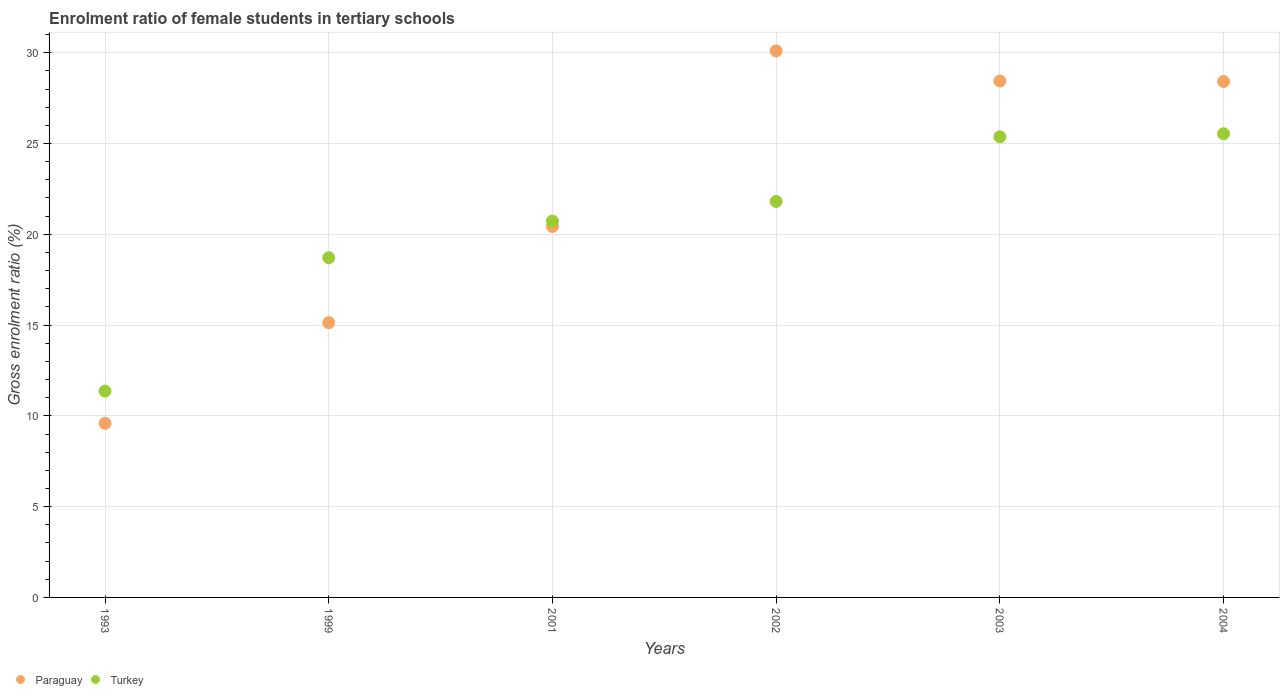How many different coloured dotlines are there?
Keep it short and to the point. 2. Is the number of dotlines equal to the number of legend labels?
Offer a terse response. Yes. What is the enrolment ratio of female students in tertiary schools in Paraguay in 1999?
Your answer should be compact. 15.14. Across all years, what is the maximum enrolment ratio of female students in tertiary schools in Paraguay?
Make the answer very short. 30.1. Across all years, what is the minimum enrolment ratio of female students in tertiary schools in Turkey?
Your answer should be very brief. 11.36. What is the total enrolment ratio of female students in tertiary schools in Turkey in the graph?
Give a very brief answer. 123.52. What is the difference between the enrolment ratio of female students in tertiary schools in Turkey in 1999 and that in 2003?
Offer a very short reply. -6.66. What is the difference between the enrolment ratio of female students in tertiary schools in Paraguay in 2003 and the enrolment ratio of female students in tertiary schools in Turkey in 2001?
Provide a succinct answer. 7.71. What is the average enrolment ratio of female students in tertiary schools in Paraguay per year?
Offer a very short reply. 22.02. In the year 1999, what is the difference between the enrolment ratio of female students in tertiary schools in Turkey and enrolment ratio of female students in tertiary schools in Paraguay?
Provide a short and direct response. 3.57. What is the ratio of the enrolment ratio of female students in tertiary schools in Turkey in 1993 to that in 2001?
Your answer should be compact. 0.55. Is the enrolment ratio of female students in tertiary schools in Turkey in 2003 less than that in 2004?
Give a very brief answer. Yes. What is the difference between the highest and the second highest enrolment ratio of female students in tertiary schools in Turkey?
Your answer should be very brief. 0.17. What is the difference between the highest and the lowest enrolment ratio of female students in tertiary schools in Paraguay?
Keep it short and to the point. 20.51. Is the sum of the enrolment ratio of female students in tertiary schools in Paraguay in 1999 and 2001 greater than the maximum enrolment ratio of female students in tertiary schools in Turkey across all years?
Ensure brevity in your answer.  Yes. Does the enrolment ratio of female students in tertiary schools in Paraguay monotonically increase over the years?
Make the answer very short. No. How many dotlines are there?
Your answer should be very brief. 2. Are the values on the major ticks of Y-axis written in scientific E-notation?
Provide a short and direct response. No. Where does the legend appear in the graph?
Make the answer very short. Bottom left. How many legend labels are there?
Ensure brevity in your answer.  2. How are the legend labels stacked?
Provide a short and direct response. Horizontal. What is the title of the graph?
Offer a terse response. Enrolment ratio of female students in tertiary schools. What is the label or title of the Y-axis?
Provide a short and direct response. Gross enrolment ratio (%). What is the Gross enrolment ratio (%) in Paraguay in 1993?
Provide a short and direct response. 9.59. What is the Gross enrolment ratio (%) of Turkey in 1993?
Give a very brief answer. 11.36. What is the Gross enrolment ratio (%) in Paraguay in 1999?
Your answer should be compact. 15.14. What is the Gross enrolment ratio (%) of Turkey in 1999?
Provide a succinct answer. 18.71. What is the Gross enrolment ratio (%) in Paraguay in 2001?
Your response must be concise. 20.43. What is the Gross enrolment ratio (%) of Turkey in 2001?
Offer a terse response. 20.73. What is the Gross enrolment ratio (%) in Paraguay in 2002?
Keep it short and to the point. 30.1. What is the Gross enrolment ratio (%) of Turkey in 2002?
Provide a succinct answer. 21.81. What is the Gross enrolment ratio (%) of Paraguay in 2003?
Make the answer very short. 28.44. What is the Gross enrolment ratio (%) of Turkey in 2003?
Your response must be concise. 25.37. What is the Gross enrolment ratio (%) in Paraguay in 2004?
Provide a short and direct response. 28.42. What is the Gross enrolment ratio (%) of Turkey in 2004?
Offer a terse response. 25.54. Across all years, what is the maximum Gross enrolment ratio (%) of Paraguay?
Make the answer very short. 30.1. Across all years, what is the maximum Gross enrolment ratio (%) of Turkey?
Offer a very short reply. 25.54. Across all years, what is the minimum Gross enrolment ratio (%) in Paraguay?
Offer a terse response. 9.59. Across all years, what is the minimum Gross enrolment ratio (%) in Turkey?
Offer a terse response. 11.36. What is the total Gross enrolment ratio (%) of Paraguay in the graph?
Give a very brief answer. 132.12. What is the total Gross enrolment ratio (%) of Turkey in the graph?
Keep it short and to the point. 123.52. What is the difference between the Gross enrolment ratio (%) of Paraguay in 1993 and that in 1999?
Give a very brief answer. -5.55. What is the difference between the Gross enrolment ratio (%) in Turkey in 1993 and that in 1999?
Your answer should be very brief. -7.34. What is the difference between the Gross enrolment ratio (%) in Paraguay in 1993 and that in 2001?
Offer a very short reply. -10.84. What is the difference between the Gross enrolment ratio (%) in Turkey in 1993 and that in 2001?
Ensure brevity in your answer.  -9.37. What is the difference between the Gross enrolment ratio (%) of Paraguay in 1993 and that in 2002?
Ensure brevity in your answer.  -20.51. What is the difference between the Gross enrolment ratio (%) in Turkey in 1993 and that in 2002?
Your answer should be compact. -10.45. What is the difference between the Gross enrolment ratio (%) in Paraguay in 1993 and that in 2003?
Provide a succinct answer. -18.85. What is the difference between the Gross enrolment ratio (%) of Turkey in 1993 and that in 2003?
Keep it short and to the point. -14.01. What is the difference between the Gross enrolment ratio (%) in Paraguay in 1993 and that in 2004?
Your answer should be compact. -18.83. What is the difference between the Gross enrolment ratio (%) of Turkey in 1993 and that in 2004?
Provide a short and direct response. -14.17. What is the difference between the Gross enrolment ratio (%) of Paraguay in 1999 and that in 2001?
Give a very brief answer. -5.29. What is the difference between the Gross enrolment ratio (%) in Turkey in 1999 and that in 2001?
Your response must be concise. -2.02. What is the difference between the Gross enrolment ratio (%) in Paraguay in 1999 and that in 2002?
Provide a succinct answer. -14.97. What is the difference between the Gross enrolment ratio (%) in Turkey in 1999 and that in 2002?
Keep it short and to the point. -3.1. What is the difference between the Gross enrolment ratio (%) in Paraguay in 1999 and that in 2003?
Provide a short and direct response. -13.31. What is the difference between the Gross enrolment ratio (%) of Turkey in 1999 and that in 2003?
Your answer should be very brief. -6.66. What is the difference between the Gross enrolment ratio (%) of Paraguay in 1999 and that in 2004?
Your answer should be compact. -13.28. What is the difference between the Gross enrolment ratio (%) of Turkey in 1999 and that in 2004?
Your answer should be very brief. -6.83. What is the difference between the Gross enrolment ratio (%) of Paraguay in 2001 and that in 2002?
Ensure brevity in your answer.  -9.67. What is the difference between the Gross enrolment ratio (%) of Turkey in 2001 and that in 2002?
Make the answer very short. -1.08. What is the difference between the Gross enrolment ratio (%) in Paraguay in 2001 and that in 2003?
Provide a succinct answer. -8.01. What is the difference between the Gross enrolment ratio (%) of Turkey in 2001 and that in 2003?
Offer a terse response. -4.64. What is the difference between the Gross enrolment ratio (%) of Paraguay in 2001 and that in 2004?
Provide a succinct answer. -7.98. What is the difference between the Gross enrolment ratio (%) of Turkey in 2001 and that in 2004?
Provide a short and direct response. -4.81. What is the difference between the Gross enrolment ratio (%) of Paraguay in 2002 and that in 2003?
Your response must be concise. 1.66. What is the difference between the Gross enrolment ratio (%) in Turkey in 2002 and that in 2003?
Offer a terse response. -3.56. What is the difference between the Gross enrolment ratio (%) of Paraguay in 2002 and that in 2004?
Keep it short and to the point. 1.69. What is the difference between the Gross enrolment ratio (%) of Turkey in 2002 and that in 2004?
Offer a very short reply. -3.73. What is the difference between the Gross enrolment ratio (%) of Paraguay in 2003 and that in 2004?
Your answer should be compact. 0.03. What is the difference between the Gross enrolment ratio (%) of Turkey in 2003 and that in 2004?
Your response must be concise. -0.17. What is the difference between the Gross enrolment ratio (%) in Paraguay in 1993 and the Gross enrolment ratio (%) in Turkey in 1999?
Your answer should be very brief. -9.12. What is the difference between the Gross enrolment ratio (%) of Paraguay in 1993 and the Gross enrolment ratio (%) of Turkey in 2001?
Your answer should be compact. -11.14. What is the difference between the Gross enrolment ratio (%) of Paraguay in 1993 and the Gross enrolment ratio (%) of Turkey in 2002?
Provide a short and direct response. -12.22. What is the difference between the Gross enrolment ratio (%) in Paraguay in 1993 and the Gross enrolment ratio (%) in Turkey in 2003?
Keep it short and to the point. -15.78. What is the difference between the Gross enrolment ratio (%) of Paraguay in 1993 and the Gross enrolment ratio (%) of Turkey in 2004?
Your response must be concise. -15.95. What is the difference between the Gross enrolment ratio (%) in Paraguay in 1999 and the Gross enrolment ratio (%) in Turkey in 2001?
Your answer should be compact. -5.59. What is the difference between the Gross enrolment ratio (%) of Paraguay in 1999 and the Gross enrolment ratio (%) of Turkey in 2002?
Your response must be concise. -6.67. What is the difference between the Gross enrolment ratio (%) of Paraguay in 1999 and the Gross enrolment ratio (%) of Turkey in 2003?
Make the answer very short. -10.23. What is the difference between the Gross enrolment ratio (%) of Paraguay in 1999 and the Gross enrolment ratio (%) of Turkey in 2004?
Give a very brief answer. -10.4. What is the difference between the Gross enrolment ratio (%) of Paraguay in 2001 and the Gross enrolment ratio (%) of Turkey in 2002?
Ensure brevity in your answer.  -1.38. What is the difference between the Gross enrolment ratio (%) of Paraguay in 2001 and the Gross enrolment ratio (%) of Turkey in 2003?
Your answer should be compact. -4.94. What is the difference between the Gross enrolment ratio (%) in Paraguay in 2001 and the Gross enrolment ratio (%) in Turkey in 2004?
Your response must be concise. -5.11. What is the difference between the Gross enrolment ratio (%) of Paraguay in 2002 and the Gross enrolment ratio (%) of Turkey in 2003?
Your response must be concise. 4.73. What is the difference between the Gross enrolment ratio (%) in Paraguay in 2002 and the Gross enrolment ratio (%) in Turkey in 2004?
Your answer should be very brief. 4.56. What is the difference between the Gross enrolment ratio (%) in Paraguay in 2003 and the Gross enrolment ratio (%) in Turkey in 2004?
Offer a very short reply. 2.91. What is the average Gross enrolment ratio (%) of Paraguay per year?
Keep it short and to the point. 22.02. What is the average Gross enrolment ratio (%) of Turkey per year?
Keep it short and to the point. 20.59. In the year 1993, what is the difference between the Gross enrolment ratio (%) in Paraguay and Gross enrolment ratio (%) in Turkey?
Keep it short and to the point. -1.77. In the year 1999, what is the difference between the Gross enrolment ratio (%) of Paraguay and Gross enrolment ratio (%) of Turkey?
Make the answer very short. -3.57. In the year 2001, what is the difference between the Gross enrolment ratio (%) in Paraguay and Gross enrolment ratio (%) in Turkey?
Your answer should be very brief. -0.3. In the year 2002, what is the difference between the Gross enrolment ratio (%) in Paraguay and Gross enrolment ratio (%) in Turkey?
Offer a very short reply. 8.29. In the year 2003, what is the difference between the Gross enrolment ratio (%) in Paraguay and Gross enrolment ratio (%) in Turkey?
Give a very brief answer. 3.07. In the year 2004, what is the difference between the Gross enrolment ratio (%) in Paraguay and Gross enrolment ratio (%) in Turkey?
Provide a succinct answer. 2.88. What is the ratio of the Gross enrolment ratio (%) of Paraguay in 1993 to that in 1999?
Your response must be concise. 0.63. What is the ratio of the Gross enrolment ratio (%) of Turkey in 1993 to that in 1999?
Your answer should be compact. 0.61. What is the ratio of the Gross enrolment ratio (%) in Paraguay in 1993 to that in 2001?
Make the answer very short. 0.47. What is the ratio of the Gross enrolment ratio (%) in Turkey in 1993 to that in 2001?
Give a very brief answer. 0.55. What is the ratio of the Gross enrolment ratio (%) in Paraguay in 1993 to that in 2002?
Offer a very short reply. 0.32. What is the ratio of the Gross enrolment ratio (%) in Turkey in 1993 to that in 2002?
Give a very brief answer. 0.52. What is the ratio of the Gross enrolment ratio (%) in Paraguay in 1993 to that in 2003?
Provide a succinct answer. 0.34. What is the ratio of the Gross enrolment ratio (%) of Turkey in 1993 to that in 2003?
Ensure brevity in your answer.  0.45. What is the ratio of the Gross enrolment ratio (%) of Paraguay in 1993 to that in 2004?
Your answer should be very brief. 0.34. What is the ratio of the Gross enrolment ratio (%) of Turkey in 1993 to that in 2004?
Offer a terse response. 0.45. What is the ratio of the Gross enrolment ratio (%) of Paraguay in 1999 to that in 2001?
Your answer should be compact. 0.74. What is the ratio of the Gross enrolment ratio (%) in Turkey in 1999 to that in 2001?
Make the answer very short. 0.9. What is the ratio of the Gross enrolment ratio (%) in Paraguay in 1999 to that in 2002?
Ensure brevity in your answer.  0.5. What is the ratio of the Gross enrolment ratio (%) in Turkey in 1999 to that in 2002?
Provide a succinct answer. 0.86. What is the ratio of the Gross enrolment ratio (%) in Paraguay in 1999 to that in 2003?
Provide a short and direct response. 0.53. What is the ratio of the Gross enrolment ratio (%) in Turkey in 1999 to that in 2003?
Provide a short and direct response. 0.74. What is the ratio of the Gross enrolment ratio (%) in Paraguay in 1999 to that in 2004?
Ensure brevity in your answer.  0.53. What is the ratio of the Gross enrolment ratio (%) in Turkey in 1999 to that in 2004?
Make the answer very short. 0.73. What is the ratio of the Gross enrolment ratio (%) in Paraguay in 2001 to that in 2002?
Give a very brief answer. 0.68. What is the ratio of the Gross enrolment ratio (%) in Turkey in 2001 to that in 2002?
Make the answer very short. 0.95. What is the ratio of the Gross enrolment ratio (%) in Paraguay in 2001 to that in 2003?
Your answer should be compact. 0.72. What is the ratio of the Gross enrolment ratio (%) of Turkey in 2001 to that in 2003?
Provide a short and direct response. 0.82. What is the ratio of the Gross enrolment ratio (%) of Paraguay in 2001 to that in 2004?
Provide a succinct answer. 0.72. What is the ratio of the Gross enrolment ratio (%) in Turkey in 2001 to that in 2004?
Make the answer very short. 0.81. What is the ratio of the Gross enrolment ratio (%) in Paraguay in 2002 to that in 2003?
Offer a terse response. 1.06. What is the ratio of the Gross enrolment ratio (%) in Turkey in 2002 to that in 2003?
Your answer should be compact. 0.86. What is the ratio of the Gross enrolment ratio (%) in Paraguay in 2002 to that in 2004?
Your response must be concise. 1.06. What is the ratio of the Gross enrolment ratio (%) of Turkey in 2002 to that in 2004?
Your answer should be very brief. 0.85. What is the difference between the highest and the second highest Gross enrolment ratio (%) in Paraguay?
Your answer should be compact. 1.66. What is the difference between the highest and the second highest Gross enrolment ratio (%) in Turkey?
Your answer should be compact. 0.17. What is the difference between the highest and the lowest Gross enrolment ratio (%) of Paraguay?
Your response must be concise. 20.51. What is the difference between the highest and the lowest Gross enrolment ratio (%) in Turkey?
Keep it short and to the point. 14.17. 